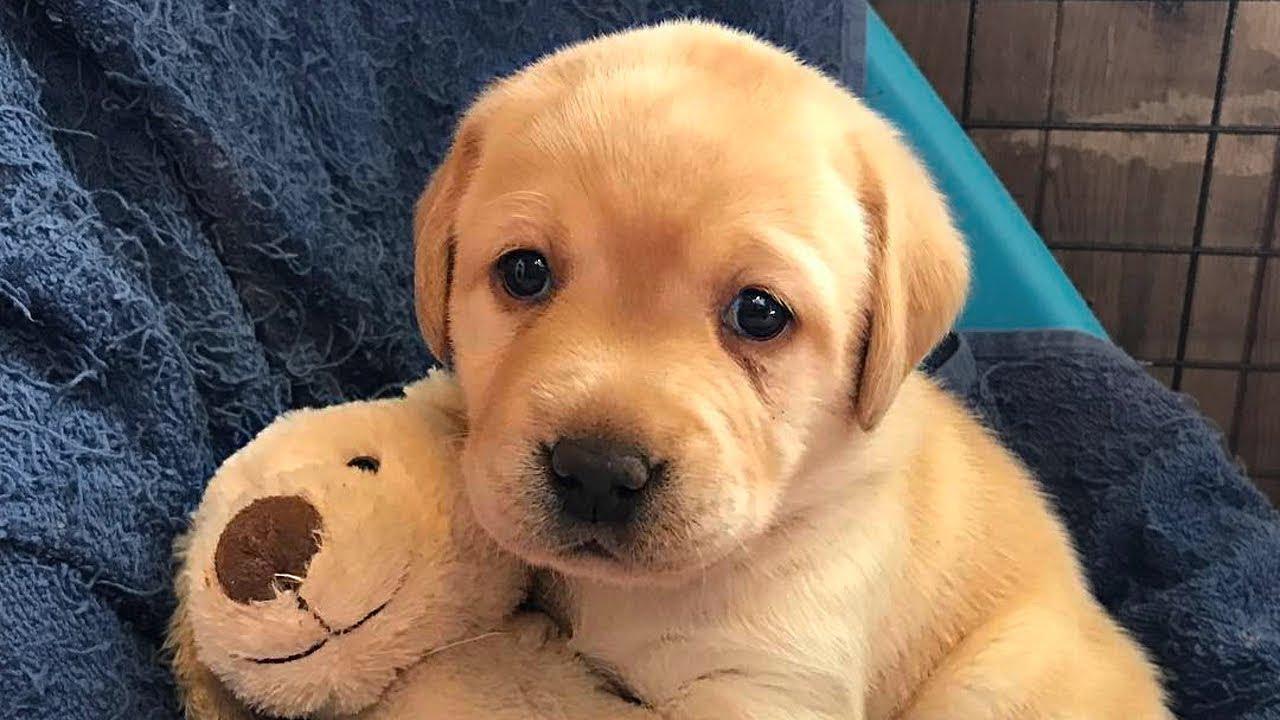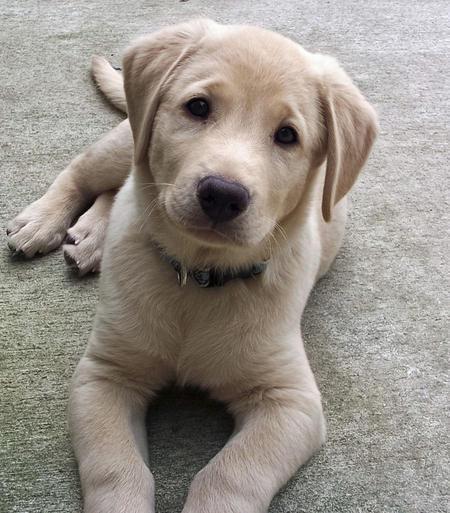The first image is the image on the left, the second image is the image on the right. For the images shown, is this caption "One dog has a toy." true? Answer yes or no. Yes. The first image is the image on the left, the second image is the image on the right. For the images shown, is this caption "No puppy is standing, and exactly one puppy is reclining with front paws extended in front of its body." true? Answer yes or no. Yes. 